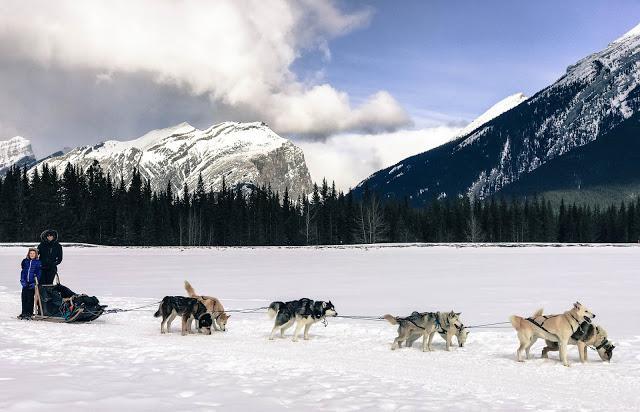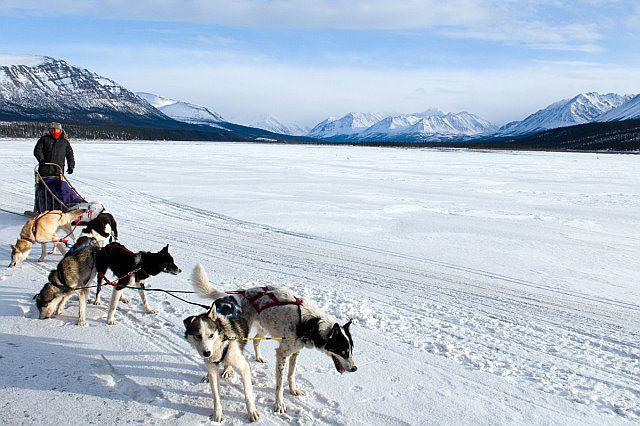The first image is the image on the left, the second image is the image on the right. For the images shown, is this caption "The dog team in the left image is heading right, and the dog team in the right image is heading left." true? Answer yes or no. No. The first image is the image on the left, the second image is the image on the right. Considering the images on both sides, is "In one of the images, a dogsled is headed towards the left." valid? Answer yes or no. No. 